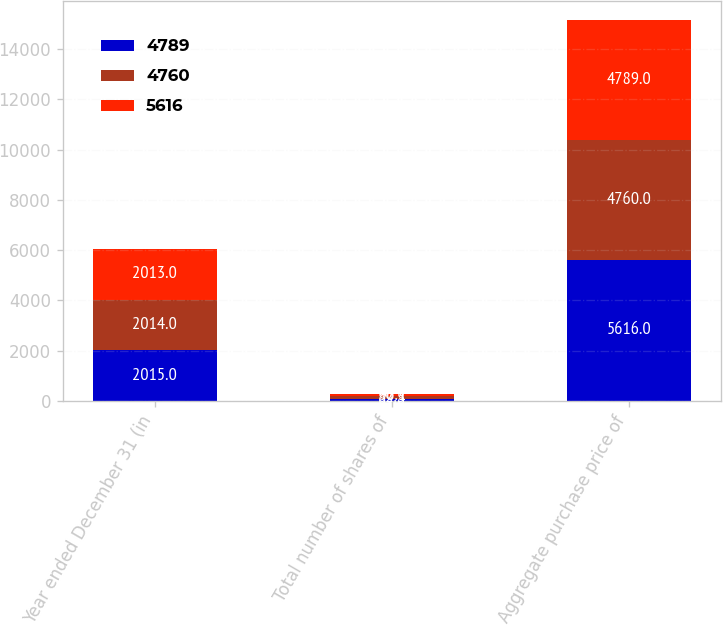<chart> <loc_0><loc_0><loc_500><loc_500><stacked_bar_chart><ecel><fcel>Year ended December 31 (in<fcel>Total number of shares of<fcel>Aggregate purchase price of<nl><fcel>4789<fcel>2015<fcel>89.8<fcel>5616<nl><fcel>4760<fcel>2014<fcel>82.3<fcel>4760<nl><fcel>5616<fcel>2013<fcel>96.1<fcel>4789<nl></chart> 